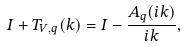<formula> <loc_0><loc_0><loc_500><loc_500>I + T _ { V , q } ( k ) = I - \frac { A _ { q } ( i k ) } { i k } ,</formula> 